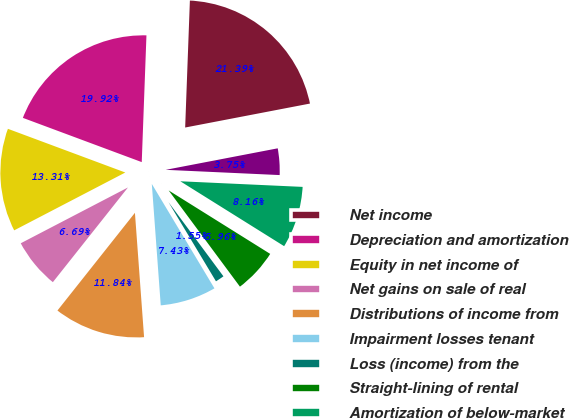<chart> <loc_0><loc_0><loc_500><loc_500><pie_chart><fcel>Net income<fcel>Depreciation and amortization<fcel>Equity in net income of<fcel>Net gains on sale of real<fcel>Distributions of income from<fcel>Impairment losses tenant<fcel>Loss (income) from the<fcel>Straight-lining of rental<fcel>Amortization of below-market<fcel>Other non-cash adjustments<nl><fcel>21.39%<fcel>19.92%<fcel>13.31%<fcel>6.69%<fcel>11.84%<fcel>7.43%<fcel>1.55%<fcel>5.96%<fcel>8.16%<fcel>3.75%<nl></chart> 